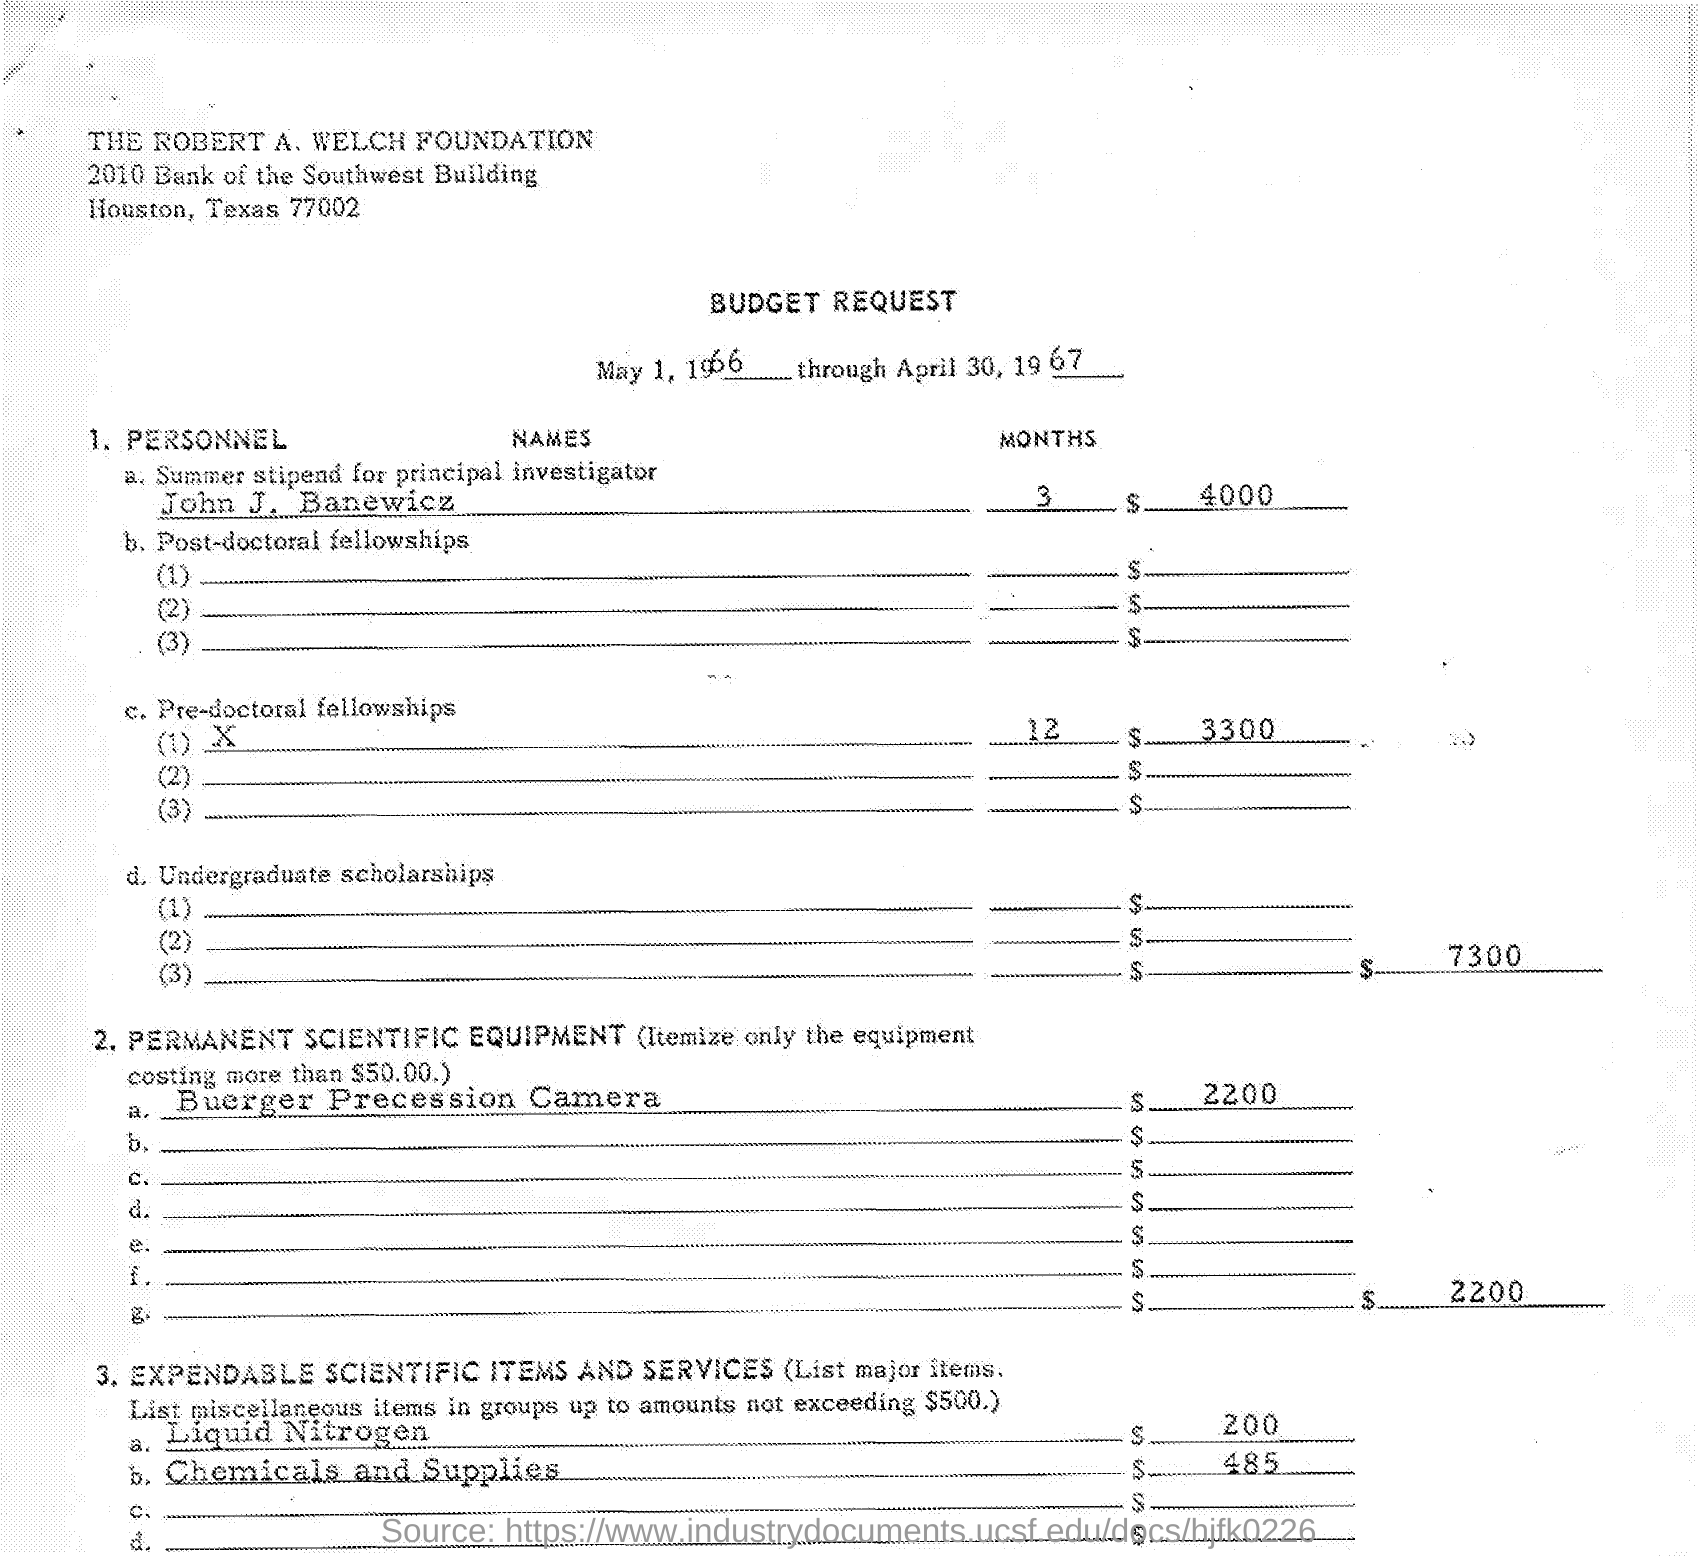What is the period?
Your answer should be compact. MAY 1, 1966 THROUGH APRIL 30, 1967. What amount is going to pay to John J. Banewicz for three months?
Keep it short and to the point. 4000. What amount is budgeted for pre doctoral fellowship?
Offer a very short reply. 3300. What is cost of liquid Nitrogen?
Make the answer very short. 200. 